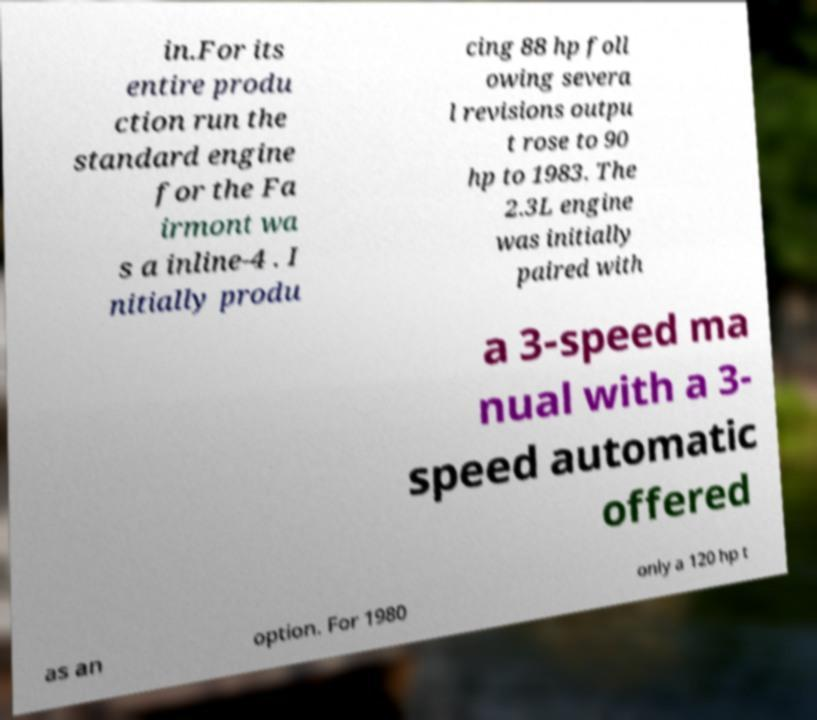I need the written content from this picture converted into text. Can you do that? in.For its entire produ ction run the standard engine for the Fa irmont wa s a inline-4 . I nitially produ cing 88 hp foll owing severa l revisions outpu t rose to 90 hp to 1983. The 2.3L engine was initially paired with a 3-speed ma nual with a 3- speed automatic offered as an option. For 1980 only a 120 hp t 